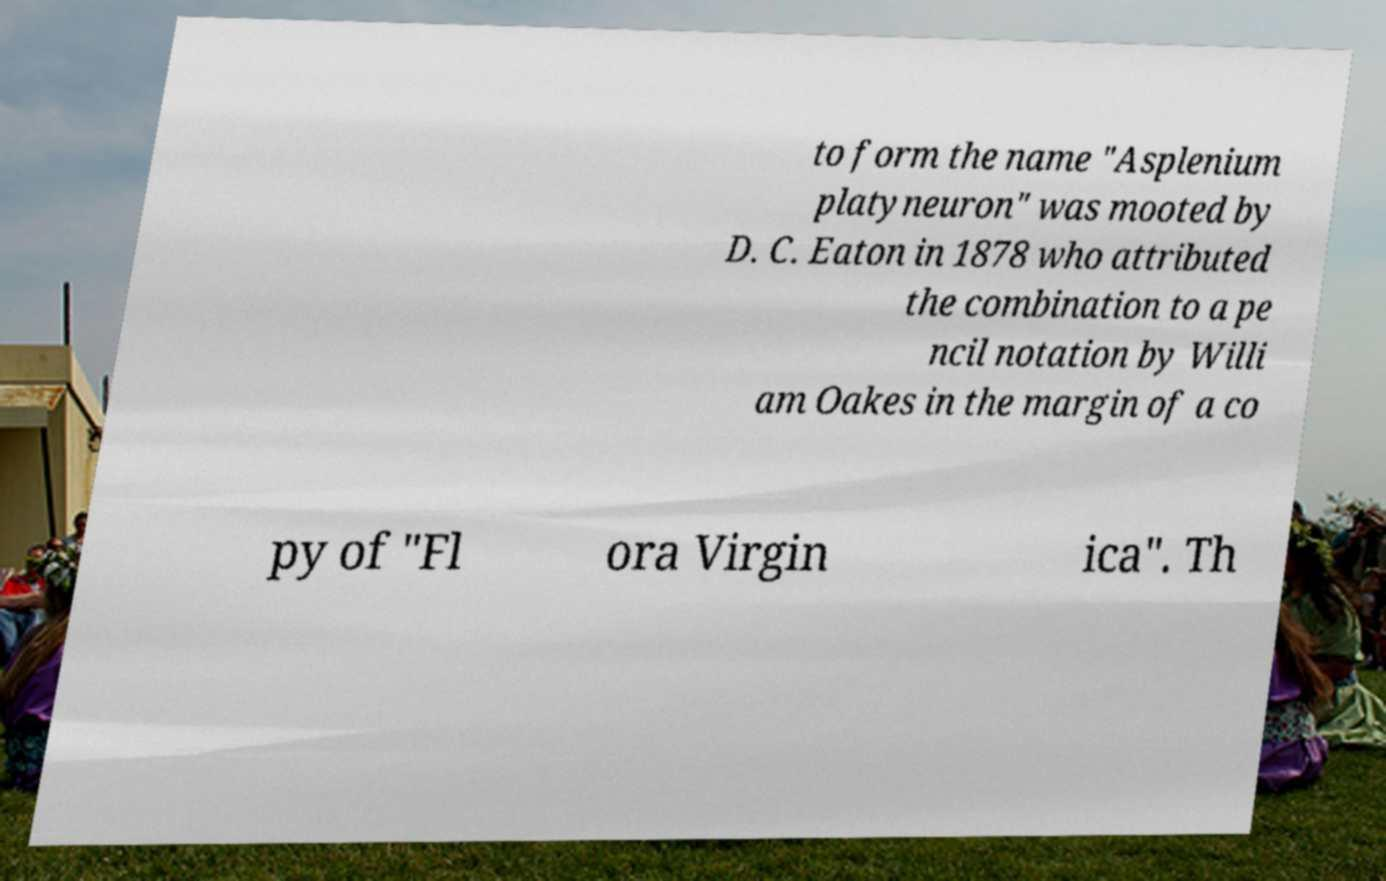Could you assist in decoding the text presented in this image and type it out clearly? to form the name "Asplenium platyneuron" was mooted by D. C. Eaton in 1878 who attributed the combination to a pe ncil notation by Willi am Oakes in the margin of a co py of "Fl ora Virgin ica". Th 